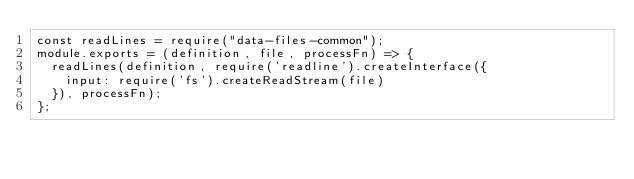Convert code to text. <code><loc_0><loc_0><loc_500><loc_500><_JavaScript_>const readLines = require("data-files-common");
module.exports = (definition, file, processFn) => {
  readLines(definition, require('readline').createInterface({
    input: require('fs').createReadStream(file)
  }), processFn);
};
</code> 